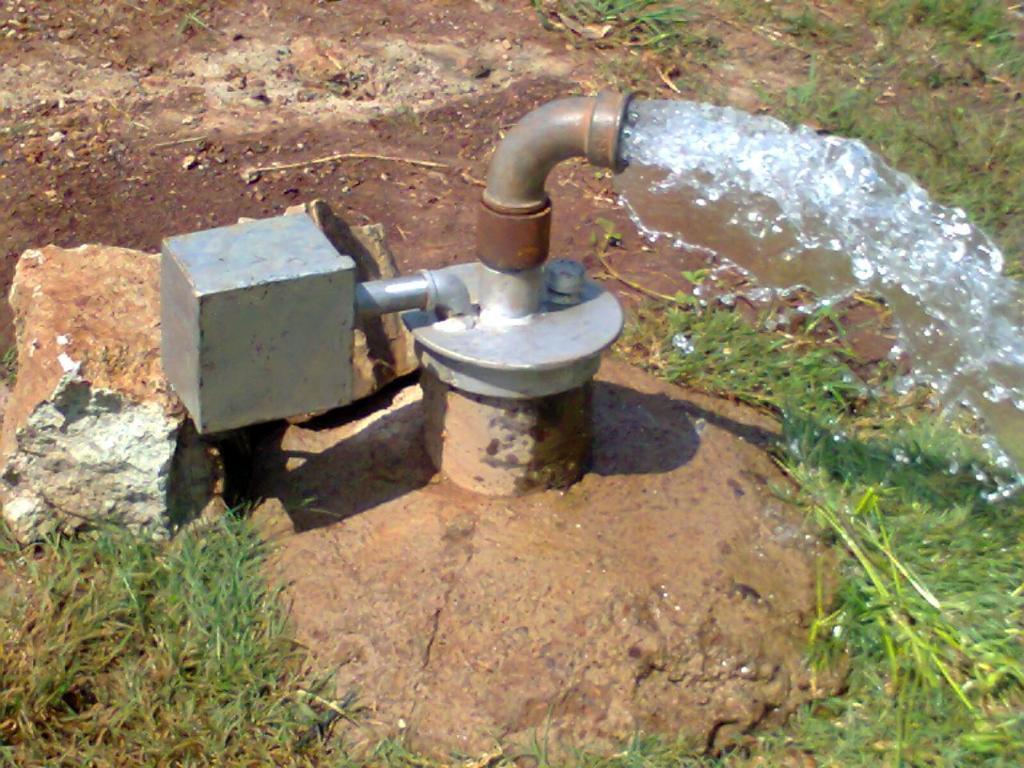Please provide a concise description of this image. This is pipe and water, these is grass. 